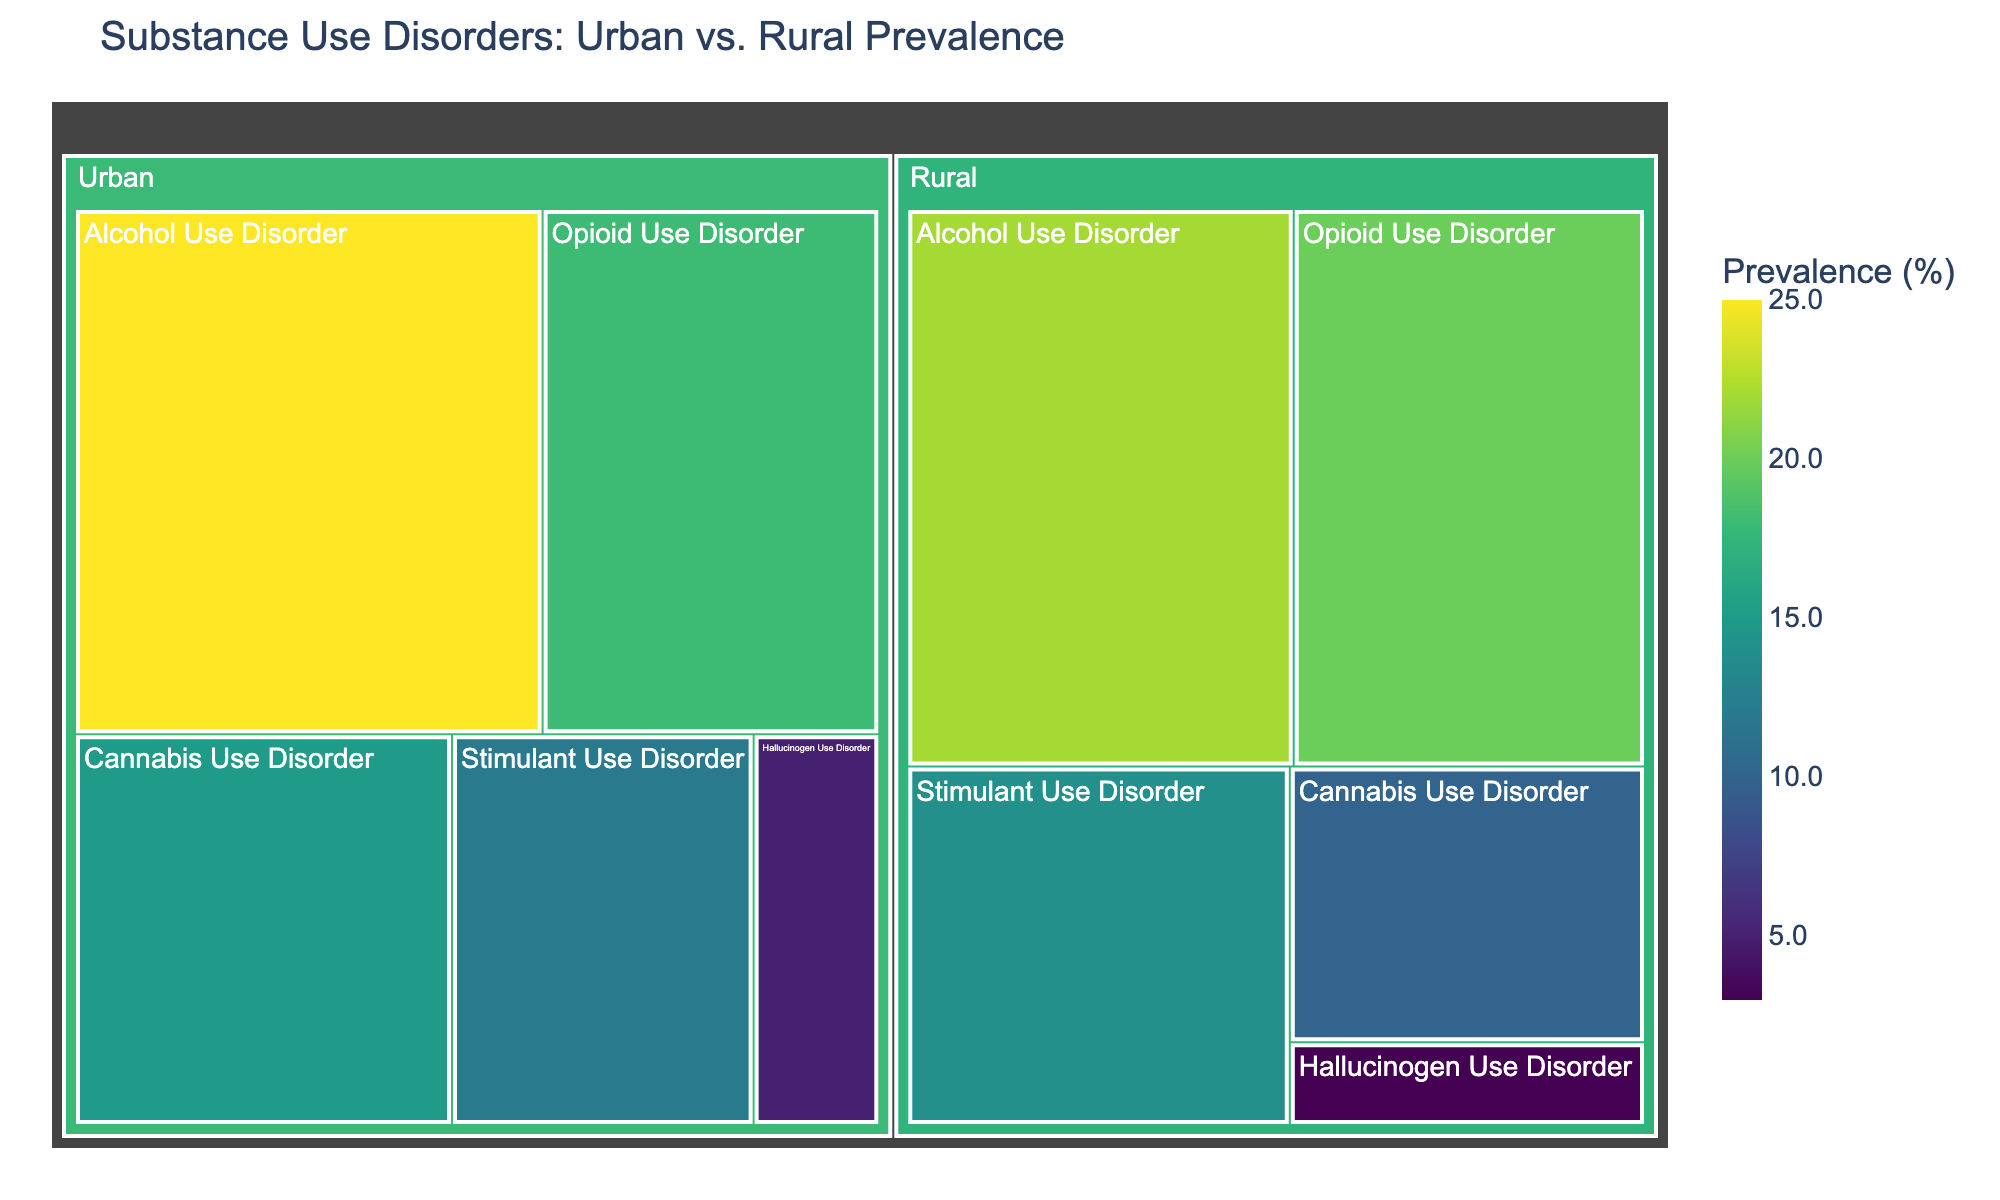What is the title of the figure? The title is displayed at the top of the figure. It provides a high-level overview of the data being visualized.
Answer: Substance Use Disorders: Urban vs. Rural Prevalence Which subcategory has the highest prevalence in urban areas? To find the highest prevalence in urban areas, look at the blocks in the 'Urban' category and identify the largest one.
Answer: Alcohol Use Disorder How much more prevalent is Opioid Use Disorder in rural areas compared to urban areas? Find the prevalence of Opioid Use Disorder in both urban and rural areas, and subtract the urban figure from the rural figure. Rural (20%) - Urban (18%) = 2% more in rural areas.
Answer: 2% What is the total prevalence of all substance use disorders in rural areas? Sum the prevalences for all subcategories in the 'Rural' category: 22% (Alcohol) + 20% (Opioid) + 14% (Stimulant) + 10% (Cannabis) + 3% (Hallucinogen) = 69%.
Answer: 69% Which category has a higher prevalence of Stimulant Use Disorder, urban or rural? Look at the Stimulant Use Disorder subcategory in both Urban and Rural categories and compare their values.
Answer: Rural Which subcategory has the lowest prevalence in urban areas? Examine all subcategories in the 'Urban' category and identify the smallest value.
Answer: Hallucinogen Use Disorder By how much does the prevalence of Alcohol Use Disorder differ between urban and rural areas? Calculate the difference between the prevalence values for Alcohol Use Disorder in urban (25%) and rural (22%) areas. 25% - 22% = 3%.
Answer: 3% What's the average prevalence of Cannabis Use Disorder in both urban and rural areas? The average is found by adding the urban and rural prevalences for Cannabis Use Disorder and dividing by 2. (15 + 10) / 2 = 12.5%.
Answer: 12.5% Which subcategory shows the greatest disparity between urban and rural areas? Calculate the differences for all subcategories' prevalences in urban and rural areas, and identify the one with the highest difference. Opioid Use Disorder has the largest absolute difference of 2% (20% - 18%).
Answer: Opioid Use Disorder What can be said about the distribution of Hallucinogen Use Disorder across urban and rural areas? Compare the values of Hallucinogen Use Disorder in both urban (5%) and rural (3%) areas to understand the distribution. It is less prevalent in rural areas than in urban areas.
Answer: Less prevalent in rural areas 